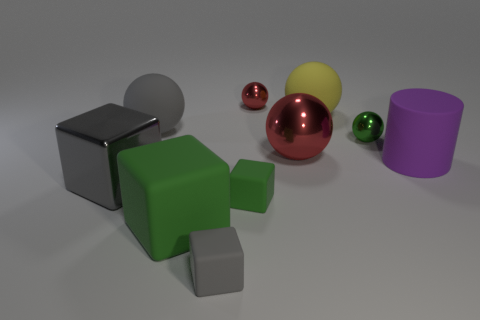Subtract 2 spheres. How many spheres are left? 3 Subtract all yellow balls. How many balls are left? 4 Subtract all yellow spheres. How many spheres are left? 4 Subtract all cyan blocks. Subtract all brown cylinders. How many blocks are left? 4 Subtract all cubes. How many objects are left? 6 Add 10 blue spheres. How many blue spheres exist? 10 Subtract 1 green balls. How many objects are left? 9 Subtract all small brown cubes. Subtract all gray objects. How many objects are left? 7 Add 4 large yellow balls. How many large yellow balls are left? 5 